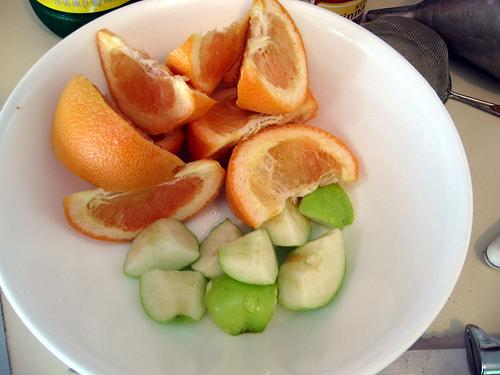Describe the scene and the objects present in the image. The image displays a white plate filled with green apple chunks, orange slices, and situated on a beige counter. A metal strainer, a brown bottle with a yellow label, a silver knife, and a metal funnel are also included on the counter. How many different types of fruit are on the plate? There are two different types of fruit on the plate: green apples and oranges. Describe the state of the apples and oranges in the image. The green apples are sliced into chunks, and the oranges are sliced into wedges. Some apples appear to be turning brown. What kitchen items are placed near the bowl filled with fruits? A metal strainer, a silver knife, and a brown bottle with a yellow label are placed near the bowl filled with fruits. What is the color of the counter in the image? The counter is beige colored. What color is the knife's handle and what is it laying on? The handle of the knife is silver and it is laying on the counter. Are there any whole fruits in the image, or are they all sliced? All fruits in the image are sliced, there are no whole fruits. What fruits are in the bowl? Green apples and orange slices are in the bowl. List all the metal objects in the image. A metal strainer, a silver knife, a metal funnel, and a silver handle are the metal objects in the image. What emotions or feelings does this image evoke? The image could evoke a sense of freshness, healthiness, and home cooking from the sliced fruits and the kitchen setting. What is the overall sentiment or mood of the image? The mood is casual and neutral, as it shows a common kitchen setup. Locate the area or object specified by the following phrase: "a chopped piece of green apple." The chopped piece of green apple is located at X:224, Y:226, Width:54, Height:54. Give your opinion on the cleanliness of the silver spoon lying on the beige colored counter on a scale from 1 to 5. There is no mention of a silver spoon in the given image information. Asking for an opinion on the cleanliness of a non-existent object will mislead the reader. Is the knife silver or gold? The knife is silver. Describe the main objects on the image. There is a white plate with fruit, a metal strainer, a beige counter, and a brown bottle with a yellow label. Have a look at the banana next to the orange slices on the plate; do you think it is ripe or overripe? Bananas are not mentioned in any of the provided image information. The inclusion of a banana will lead to a misleading understanding of the image. What are the actions happening between the objects in the image? There is no direct action between the objects, but some fruits are sliced and a strainer, knife, and bottle are placed nearby. Can you see any text on the brown bottle with a yellow label? No, there is no visible text on the bottle. What type of apples are in the bowl? Granny Smith apples are in the bowl. Please notice the blue cup by the beige counter at the bottom right corner of the image. It has a handle and is filled with a liquid. There is no mention of a blue cup or any type of liquid in the given image information. This will lead to confusion when trying to identify such a non-existent object. Is the metal strainer handheld or standing? The metal strainer is handheld. Does the fruit on the plate look fresh or old? The fruit looks old. On a scale of 1 to 10, how well does the wooden cutting board appear to be cleaned, considering it is placed right next to the metal strainer? There is no wooden cutting board mentioned in the given image information. This question assumes something that isn't present in the image and will confuse the reader. What types of objects are laying on the counter besides a white plate? A metal strainer, a beige colored counter section, a white handle, a metal object, and a metal funnel are laying on the counter. What kinds of fruit can you find on the plate? Green apples cut into chunks and orange slices. Evaluate the organization and composition of items in the image. The composition is relatively organized, with the bowl of fruit being the main focus and other objects placed around it. Read any text present in the image. There is no text present in the image. Identify any unusual or unexpected elements in the image. No unusual elements detected. The items are common in a kitchen setup. Are the apples and oranges in separate containers or the same one? The apples and oranges are in the same container, a white bowl. Can you point out the purple grapes in the image? They should be located close to the sliced green apples. There are no purple grapes mentioned in any of the given image information. Thus, asking someone to identify them will be misleading. Identify the red strawberries scattered around the white plate with fruit. Are they ripe or not? Strawberries are not mentioned in any of the provided image information. The only fruits mentioned are apples and oranges; thus, discussing strawberries would be misleading. What is the color of the apple's skin? The apple's skin is green. 